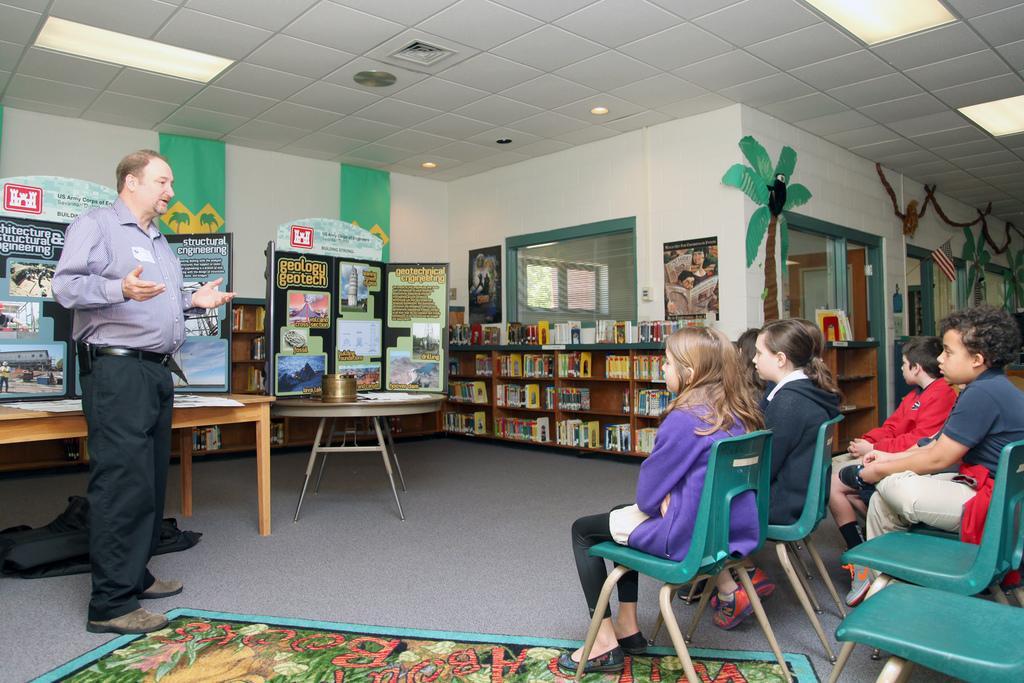Can you describe this image briefly? There are group of people in the image. At the left side of the image there is a person speaking to the kids who are sitting on the chairs and at the middle of the image there are books and paintings. At the top of the image there are lights 